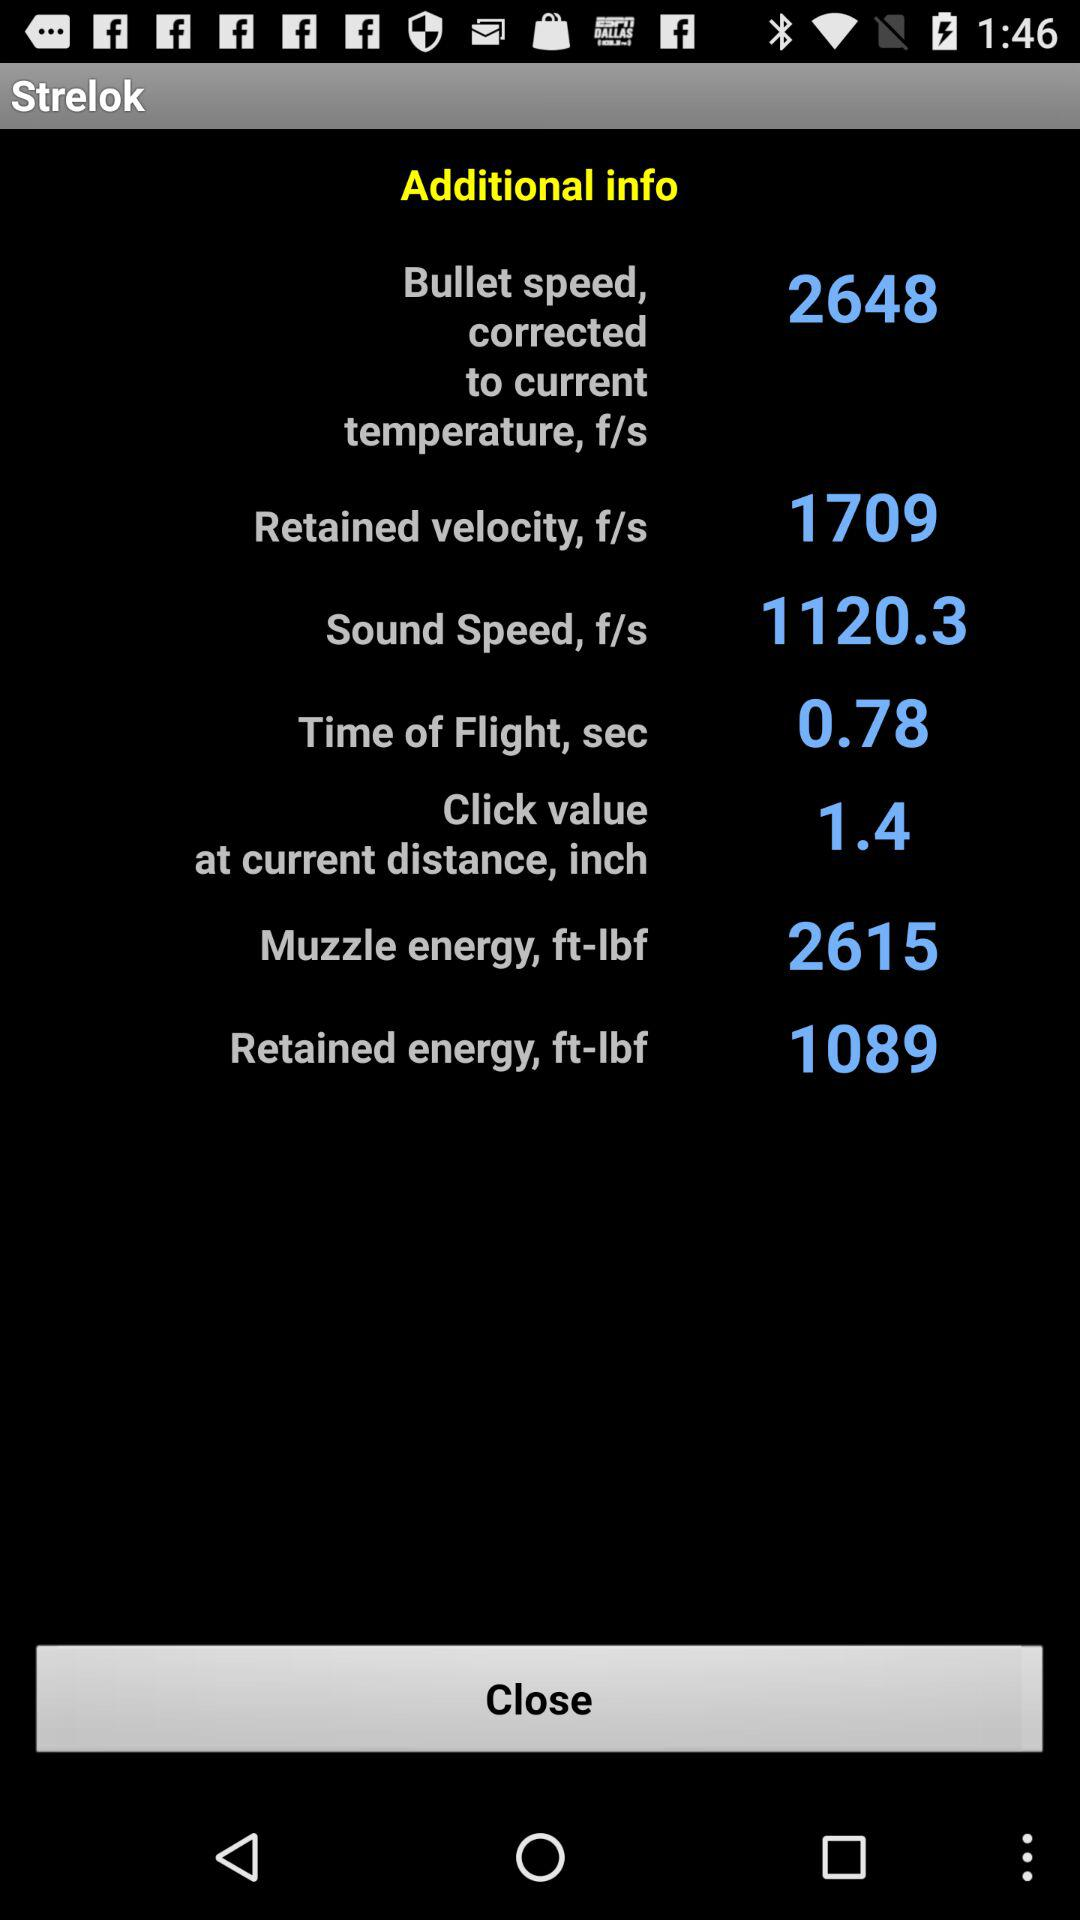What is the time of flight? The time of flight is 0.78 seconds. 